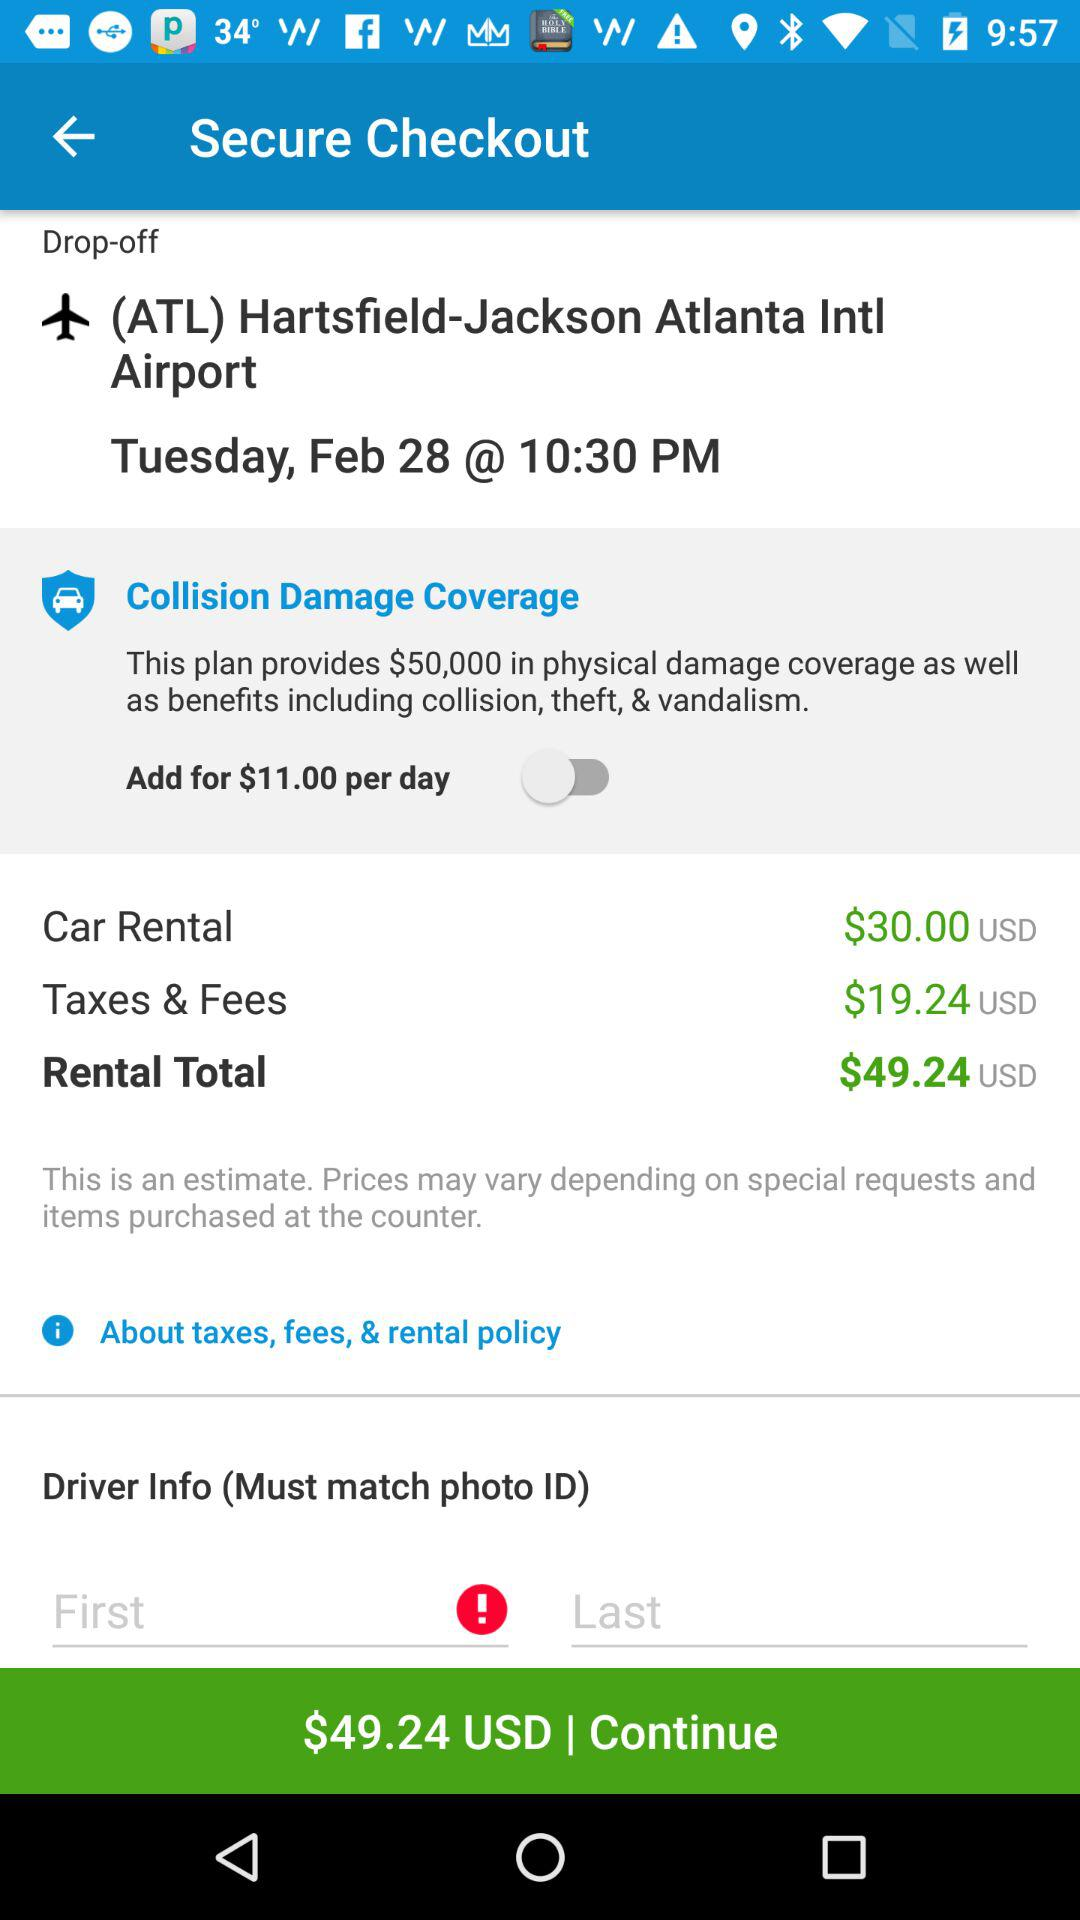What is the drop-off location? The drop-off location is "(ATL) Hartsfield-Jackson Atlanta Intl Airport". 